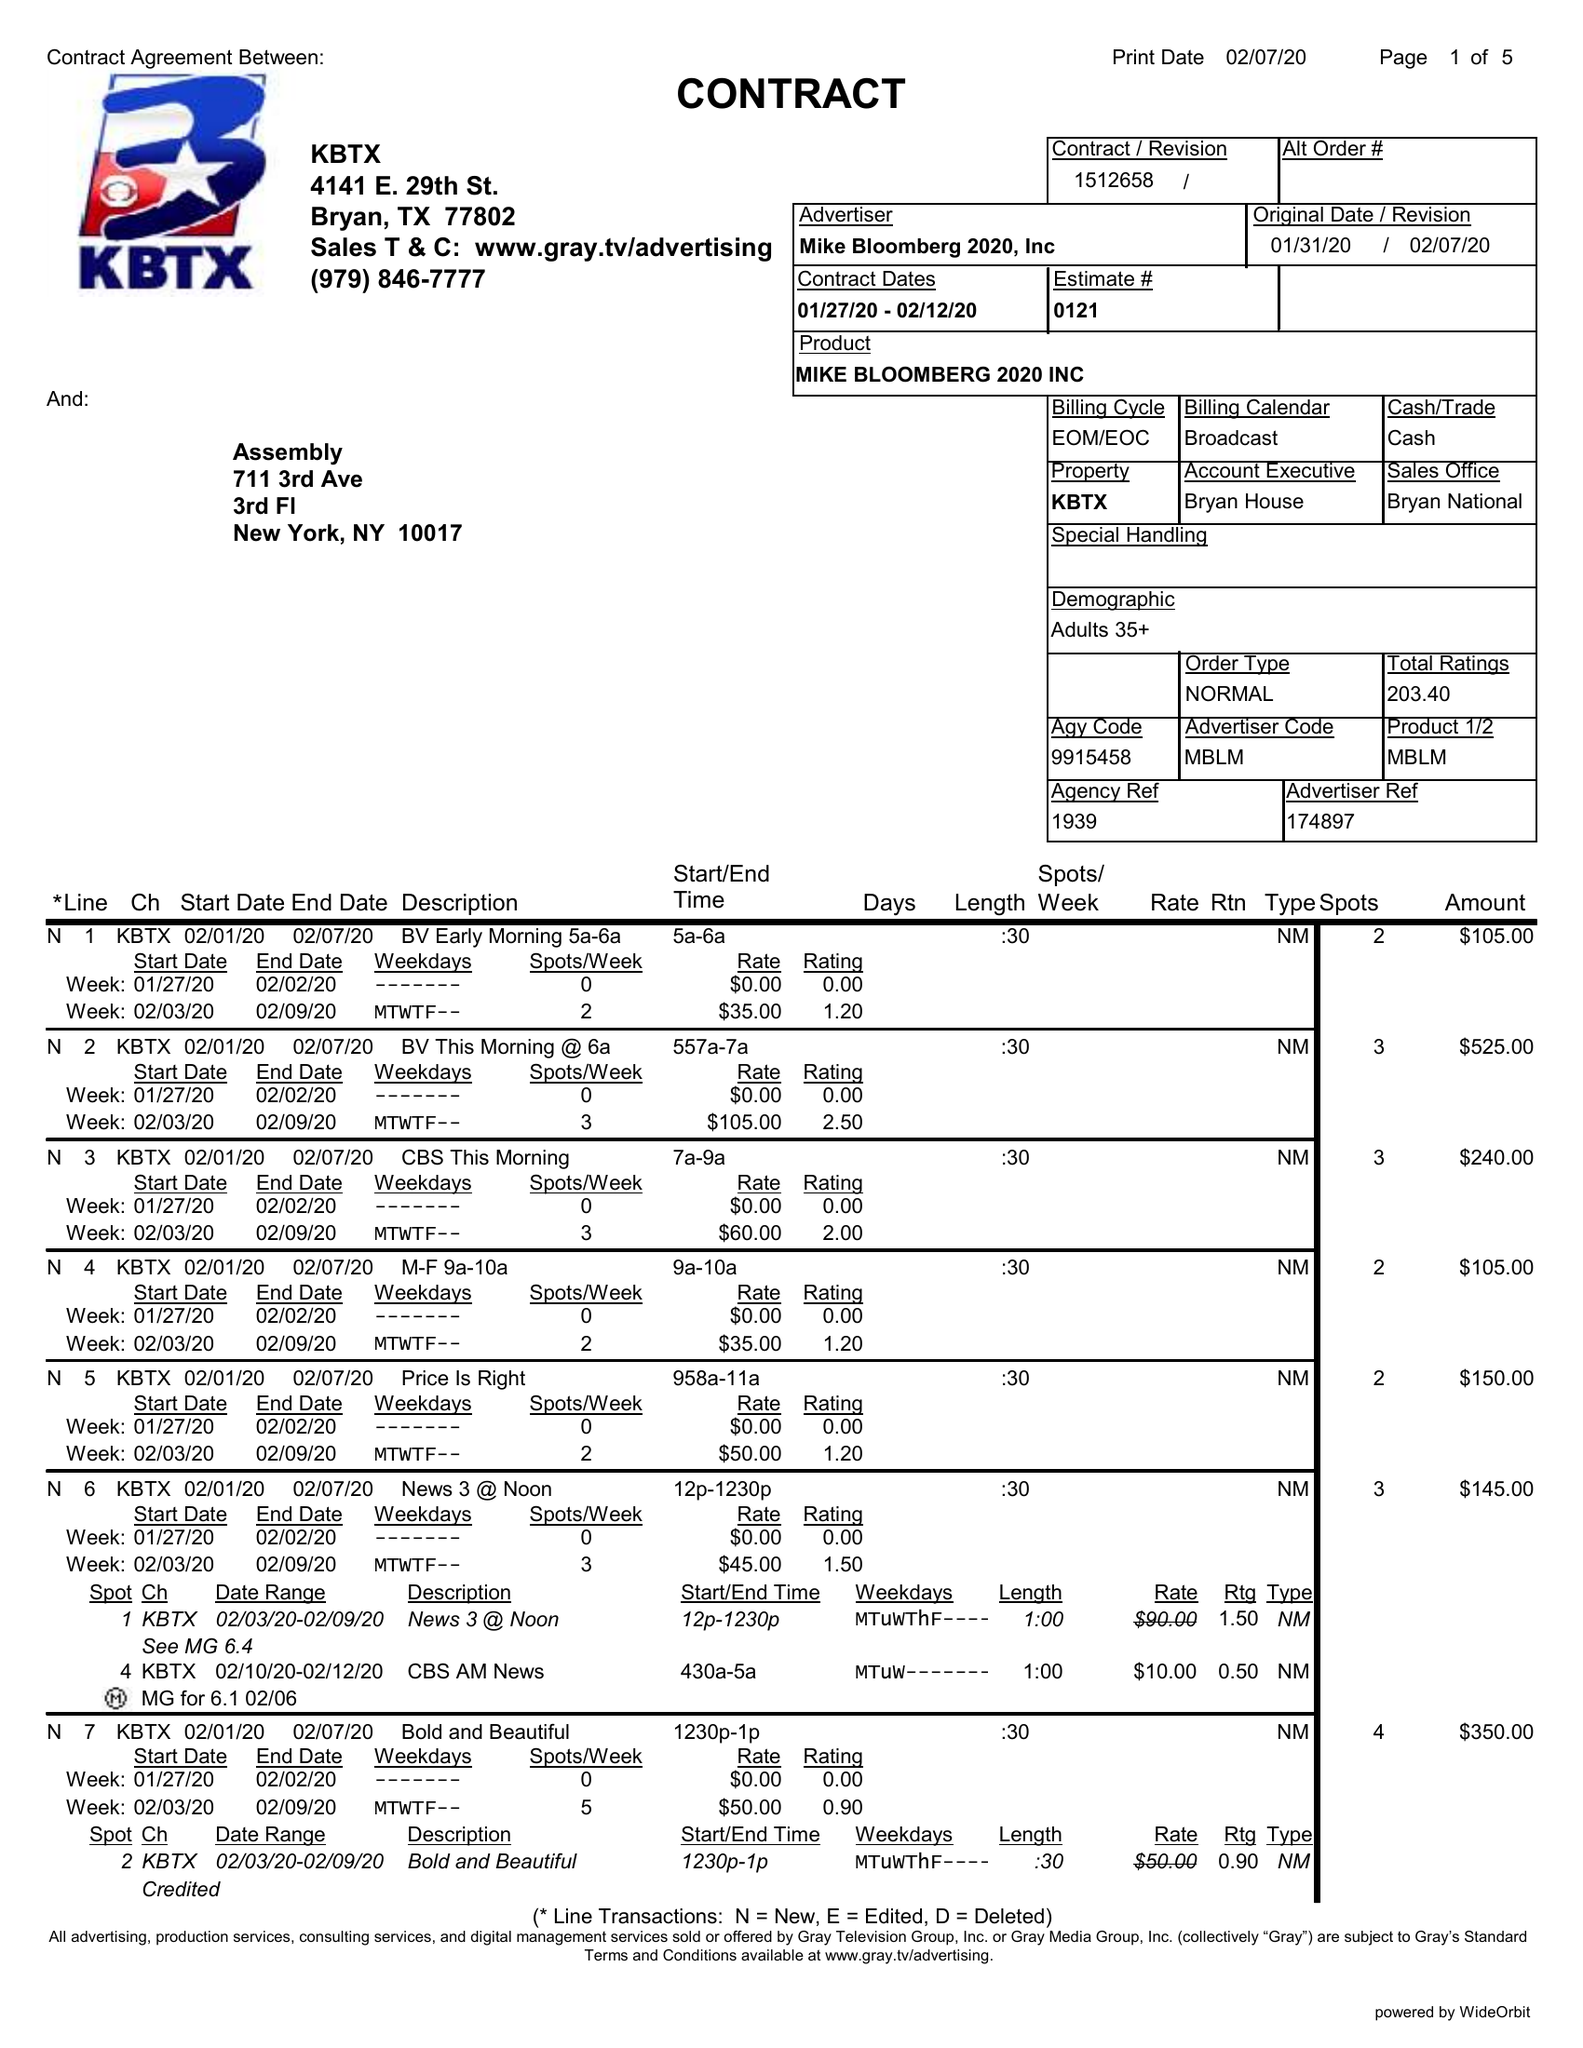What is the value for the gross_amount?
Answer the question using a single word or phrase. 19975.00 